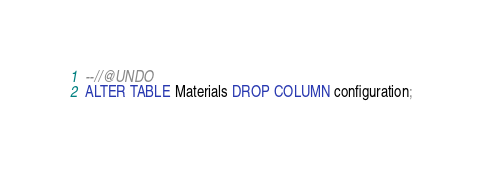<code> <loc_0><loc_0><loc_500><loc_500><_SQL_>--//@UNDO
ALTER TABLE Materials DROP COLUMN configuration;


</code> 